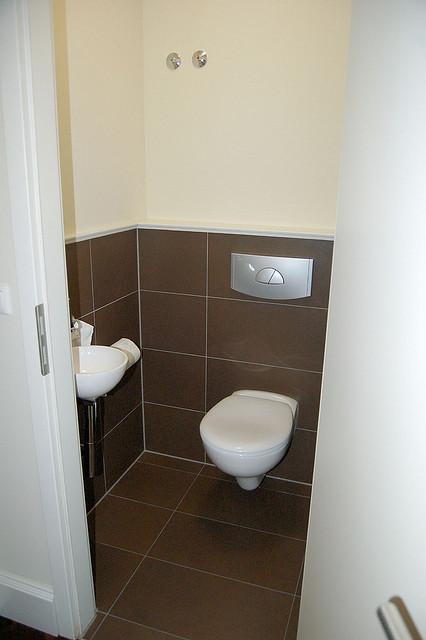What color is the toilet?
Short answer required. White. Is the toilet lid down?
Keep it brief. Yes. How many tiles are in the shot?
Give a very brief answer. 25. What sort of room is this?
Keep it brief. Bathroom. What color is the tile?
Be succinct. Brown. 